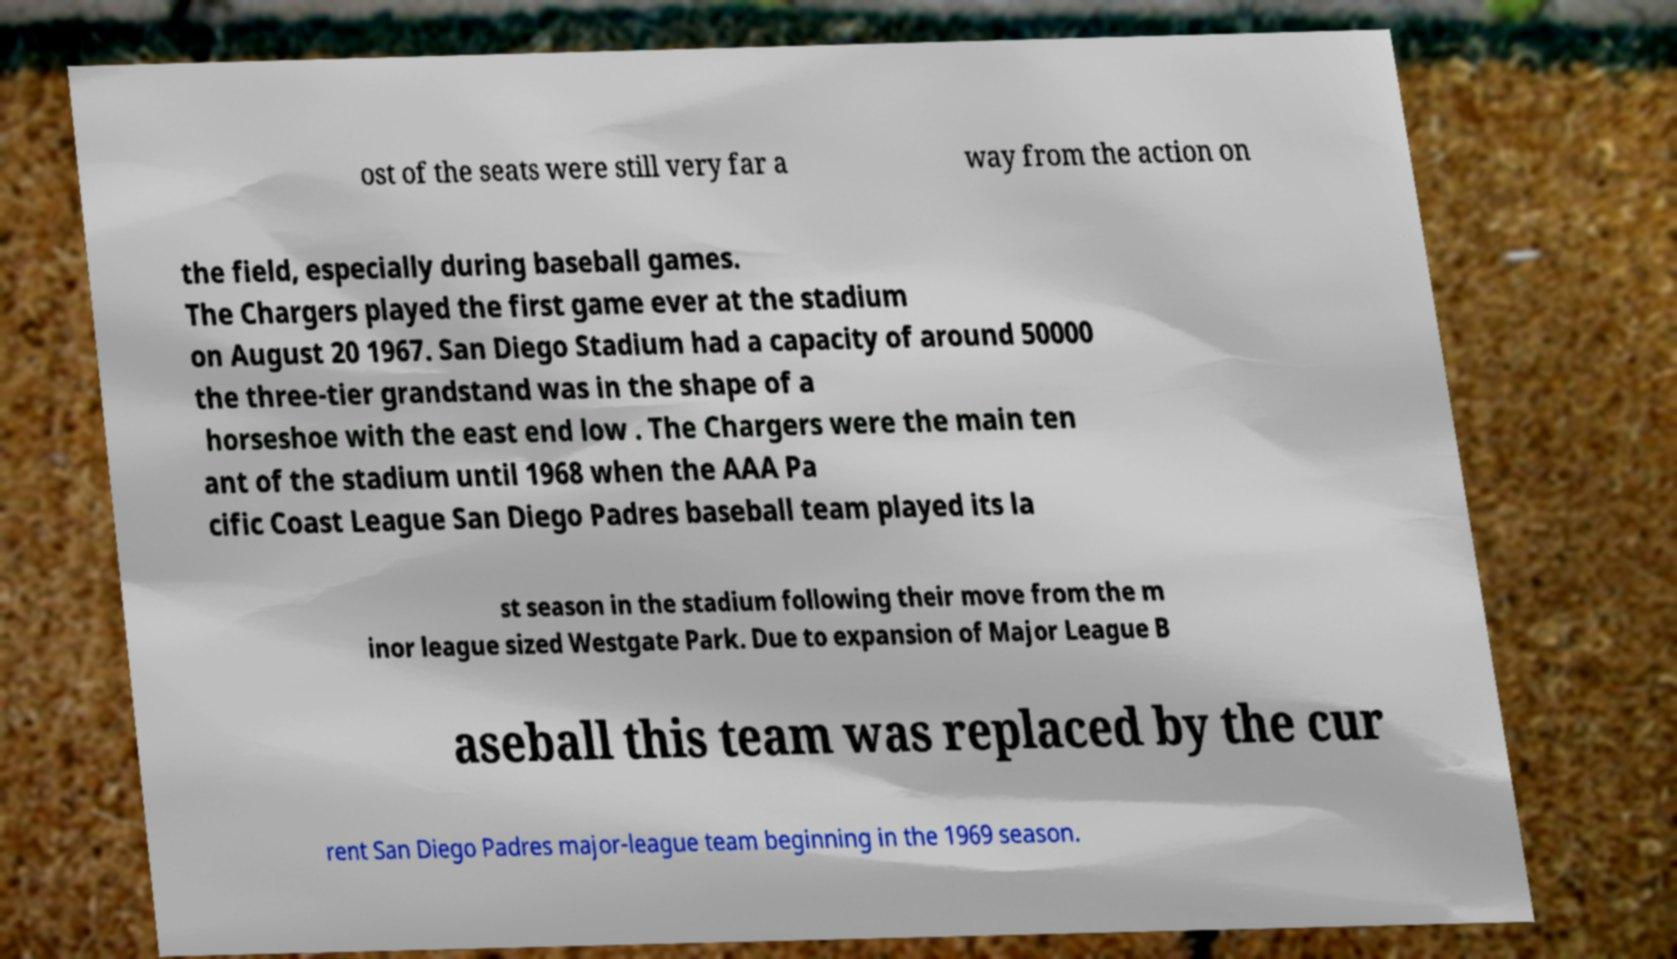Can you read and provide the text displayed in the image?This photo seems to have some interesting text. Can you extract and type it out for me? ost of the seats were still very far a way from the action on the field, especially during baseball games. The Chargers played the first game ever at the stadium on August 20 1967. San Diego Stadium had a capacity of around 50000 the three-tier grandstand was in the shape of a horseshoe with the east end low . The Chargers were the main ten ant of the stadium until 1968 when the AAA Pa cific Coast League San Diego Padres baseball team played its la st season in the stadium following their move from the m inor league sized Westgate Park. Due to expansion of Major League B aseball this team was replaced by the cur rent San Diego Padres major-league team beginning in the 1969 season. 